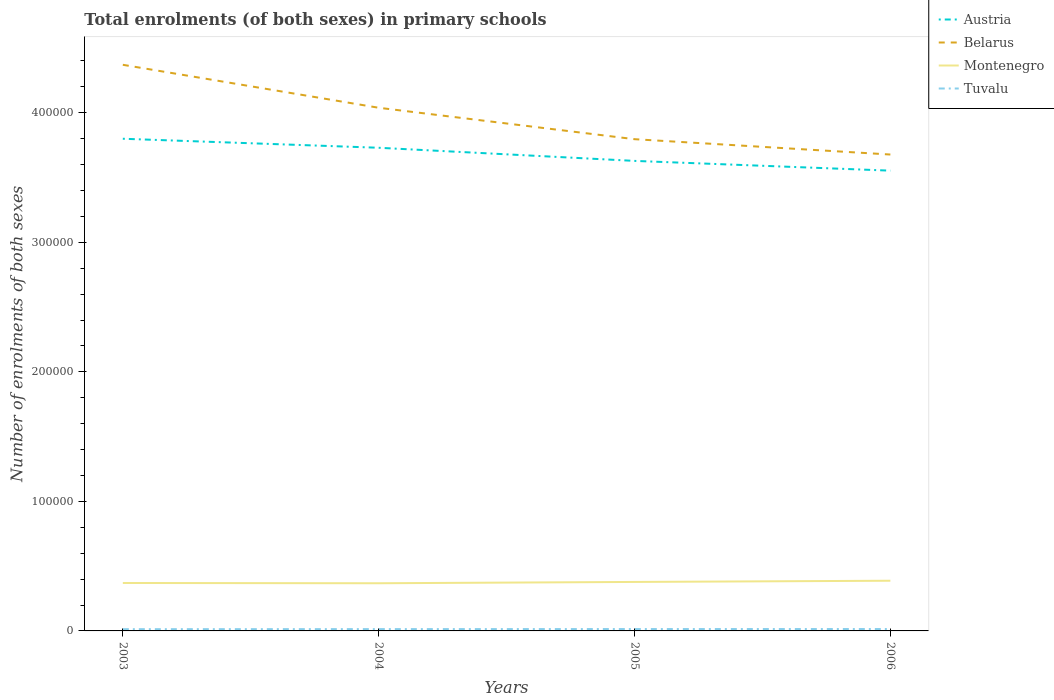How many different coloured lines are there?
Offer a very short reply. 4. Is the number of lines equal to the number of legend labels?
Provide a short and direct response. Yes. Across all years, what is the maximum number of enrolments in primary schools in Belarus?
Your answer should be compact. 3.68e+05. In which year was the number of enrolments in primary schools in Montenegro maximum?
Give a very brief answer. 2004. What is the total number of enrolments in primary schools in Belarus in the graph?
Offer a terse response. 5.74e+04. What is the difference between the highest and the second highest number of enrolments in primary schools in Montenegro?
Provide a short and direct response. 1947. What is the difference between the highest and the lowest number of enrolments in primary schools in Montenegro?
Provide a succinct answer. 2. Is the number of enrolments in primary schools in Montenegro strictly greater than the number of enrolments in primary schools in Austria over the years?
Offer a very short reply. Yes. How many lines are there?
Your answer should be compact. 4. What is the difference between two consecutive major ticks on the Y-axis?
Offer a terse response. 1.00e+05. Are the values on the major ticks of Y-axis written in scientific E-notation?
Provide a short and direct response. No. Where does the legend appear in the graph?
Keep it short and to the point. Top right. How many legend labels are there?
Give a very brief answer. 4. What is the title of the graph?
Offer a terse response. Total enrolments (of both sexes) in primary schools. What is the label or title of the X-axis?
Keep it short and to the point. Years. What is the label or title of the Y-axis?
Keep it short and to the point. Number of enrolments of both sexes. What is the Number of enrolments of both sexes of Austria in 2003?
Make the answer very short. 3.80e+05. What is the Number of enrolments of both sexes in Belarus in 2003?
Keep it short and to the point. 4.37e+05. What is the Number of enrolments of both sexes of Montenegro in 2003?
Your answer should be compact. 3.70e+04. What is the Number of enrolments of both sexes of Tuvalu in 2003?
Give a very brief answer. 1344. What is the Number of enrolments of both sexes of Austria in 2004?
Make the answer very short. 3.73e+05. What is the Number of enrolments of both sexes of Belarus in 2004?
Give a very brief answer. 4.04e+05. What is the Number of enrolments of both sexes in Montenegro in 2004?
Provide a succinct answer. 3.68e+04. What is the Number of enrolments of both sexes in Tuvalu in 2004?
Offer a terse response. 1404. What is the Number of enrolments of both sexes of Austria in 2005?
Ensure brevity in your answer.  3.63e+05. What is the Number of enrolments of both sexes in Belarus in 2005?
Give a very brief answer. 3.80e+05. What is the Number of enrolments of both sexes of Montenegro in 2005?
Offer a very short reply. 3.78e+04. What is the Number of enrolments of both sexes in Tuvalu in 2005?
Your response must be concise. 1450. What is the Number of enrolments of both sexes of Austria in 2006?
Keep it short and to the point. 3.55e+05. What is the Number of enrolments of both sexes of Belarus in 2006?
Make the answer very short. 3.68e+05. What is the Number of enrolments of both sexes in Montenegro in 2006?
Provide a short and direct response. 3.87e+04. What is the Number of enrolments of both sexes of Tuvalu in 2006?
Your response must be concise. 1460. Across all years, what is the maximum Number of enrolments of both sexes in Austria?
Keep it short and to the point. 3.80e+05. Across all years, what is the maximum Number of enrolments of both sexes of Belarus?
Your response must be concise. 4.37e+05. Across all years, what is the maximum Number of enrolments of both sexes of Montenegro?
Provide a succinct answer. 3.87e+04. Across all years, what is the maximum Number of enrolments of both sexes in Tuvalu?
Your answer should be compact. 1460. Across all years, what is the minimum Number of enrolments of both sexes of Austria?
Offer a terse response. 3.55e+05. Across all years, what is the minimum Number of enrolments of both sexes of Belarus?
Make the answer very short. 3.68e+05. Across all years, what is the minimum Number of enrolments of both sexes in Montenegro?
Provide a short and direct response. 3.68e+04. Across all years, what is the minimum Number of enrolments of both sexes in Tuvalu?
Your response must be concise. 1344. What is the total Number of enrolments of both sexes of Austria in the graph?
Your answer should be very brief. 1.47e+06. What is the total Number of enrolments of both sexes of Belarus in the graph?
Give a very brief answer. 1.59e+06. What is the total Number of enrolments of both sexes in Montenegro in the graph?
Ensure brevity in your answer.  1.50e+05. What is the total Number of enrolments of both sexes in Tuvalu in the graph?
Your answer should be very brief. 5658. What is the difference between the Number of enrolments of both sexes in Austria in 2003 and that in 2004?
Your response must be concise. 6957. What is the difference between the Number of enrolments of both sexes in Belarus in 2003 and that in 2004?
Make the answer very short. 3.32e+04. What is the difference between the Number of enrolments of both sexes of Montenegro in 2003 and that in 2004?
Offer a terse response. 216. What is the difference between the Number of enrolments of both sexes of Tuvalu in 2003 and that in 2004?
Make the answer very short. -60. What is the difference between the Number of enrolments of both sexes in Austria in 2003 and that in 2005?
Your answer should be very brief. 1.71e+04. What is the difference between the Number of enrolments of both sexes in Belarus in 2003 and that in 2005?
Your response must be concise. 5.74e+04. What is the difference between the Number of enrolments of both sexes in Montenegro in 2003 and that in 2005?
Offer a very short reply. -803. What is the difference between the Number of enrolments of both sexes of Tuvalu in 2003 and that in 2005?
Keep it short and to the point. -106. What is the difference between the Number of enrolments of both sexes in Austria in 2003 and that in 2006?
Your answer should be very brief. 2.46e+04. What is the difference between the Number of enrolments of both sexes in Belarus in 2003 and that in 2006?
Provide a short and direct response. 6.93e+04. What is the difference between the Number of enrolments of both sexes in Montenegro in 2003 and that in 2006?
Ensure brevity in your answer.  -1731. What is the difference between the Number of enrolments of both sexes in Tuvalu in 2003 and that in 2006?
Offer a terse response. -116. What is the difference between the Number of enrolments of both sexes of Austria in 2004 and that in 2005?
Give a very brief answer. 1.01e+04. What is the difference between the Number of enrolments of both sexes in Belarus in 2004 and that in 2005?
Provide a short and direct response. 2.43e+04. What is the difference between the Number of enrolments of both sexes of Montenegro in 2004 and that in 2005?
Offer a very short reply. -1019. What is the difference between the Number of enrolments of both sexes of Tuvalu in 2004 and that in 2005?
Provide a short and direct response. -46. What is the difference between the Number of enrolments of both sexes in Austria in 2004 and that in 2006?
Provide a succinct answer. 1.77e+04. What is the difference between the Number of enrolments of both sexes in Belarus in 2004 and that in 2006?
Your response must be concise. 3.61e+04. What is the difference between the Number of enrolments of both sexes in Montenegro in 2004 and that in 2006?
Give a very brief answer. -1947. What is the difference between the Number of enrolments of both sexes in Tuvalu in 2004 and that in 2006?
Make the answer very short. -56. What is the difference between the Number of enrolments of both sexes of Austria in 2005 and that in 2006?
Make the answer very short. 7529. What is the difference between the Number of enrolments of both sexes in Belarus in 2005 and that in 2006?
Give a very brief answer. 1.18e+04. What is the difference between the Number of enrolments of both sexes in Montenegro in 2005 and that in 2006?
Provide a succinct answer. -928. What is the difference between the Number of enrolments of both sexes of Tuvalu in 2005 and that in 2006?
Keep it short and to the point. -10. What is the difference between the Number of enrolments of both sexes in Austria in 2003 and the Number of enrolments of both sexes in Belarus in 2004?
Your response must be concise. -2.39e+04. What is the difference between the Number of enrolments of both sexes in Austria in 2003 and the Number of enrolments of both sexes in Montenegro in 2004?
Ensure brevity in your answer.  3.43e+05. What is the difference between the Number of enrolments of both sexes in Austria in 2003 and the Number of enrolments of both sexes in Tuvalu in 2004?
Your answer should be very brief. 3.79e+05. What is the difference between the Number of enrolments of both sexes in Belarus in 2003 and the Number of enrolments of both sexes in Montenegro in 2004?
Your response must be concise. 4.00e+05. What is the difference between the Number of enrolments of both sexes in Belarus in 2003 and the Number of enrolments of both sexes in Tuvalu in 2004?
Offer a terse response. 4.36e+05. What is the difference between the Number of enrolments of both sexes in Montenegro in 2003 and the Number of enrolments of both sexes in Tuvalu in 2004?
Your answer should be very brief. 3.56e+04. What is the difference between the Number of enrolments of both sexes in Austria in 2003 and the Number of enrolments of both sexes in Belarus in 2005?
Make the answer very short. 343. What is the difference between the Number of enrolments of both sexes of Austria in 2003 and the Number of enrolments of both sexes of Montenegro in 2005?
Offer a very short reply. 3.42e+05. What is the difference between the Number of enrolments of both sexes of Austria in 2003 and the Number of enrolments of both sexes of Tuvalu in 2005?
Your response must be concise. 3.78e+05. What is the difference between the Number of enrolments of both sexes of Belarus in 2003 and the Number of enrolments of both sexes of Montenegro in 2005?
Provide a short and direct response. 3.99e+05. What is the difference between the Number of enrolments of both sexes of Belarus in 2003 and the Number of enrolments of both sexes of Tuvalu in 2005?
Offer a very short reply. 4.36e+05. What is the difference between the Number of enrolments of both sexes of Montenegro in 2003 and the Number of enrolments of both sexes of Tuvalu in 2005?
Keep it short and to the point. 3.56e+04. What is the difference between the Number of enrolments of both sexes of Austria in 2003 and the Number of enrolments of both sexes of Belarus in 2006?
Your answer should be very brief. 1.22e+04. What is the difference between the Number of enrolments of both sexes of Austria in 2003 and the Number of enrolments of both sexes of Montenegro in 2006?
Your answer should be compact. 3.41e+05. What is the difference between the Number of enrolments of both sexes in Austria in 2003 and the Number of enrolments of both sexes in Tuvalu in 2006?
Your answer should be very brief. 3.78e+05. What is the difference between the Number of enrolments of both sexes in Belarus in 2003 and the Number of enrolments of both sexes in Montenegro in 2006?
Offer a terse response. 3.98e+05. What is the difference between the Number of enrolments of both sexes in Belarus in 2003 and the Number of enrolments of both sexes in Tuvalu in 2006?
Offer a terse response. 4.36e+05. What is the difference between the Number of enrolments of both sexes in Montenegro in 2003 and the Number of enrolments of both sexes in Tuvalu in 2006?
Offer a very short reply. 3.55e+04. What is the difference between the Number of enrolments of both sexes of Austria in 2004 and the Number of enrolments of both sexes of Belarus in 2005?
Provide a short and direct response. -6614. What is the difference between the Number of enrolments of both sexes in Austria in 2004 and the Number of enrolments of both sexes in Montenegro in 2005?
Your answer should be very brief. 3.35e+05. What is the difference between the Number of enrolments of both sexes in Austria in 2004 and the Number of enrolments of both sexes in Tuvalu in 2005?
Your answer should be very brief. 3.72e+05. What is the difference between the Number of enrolments of both sexes of Belarus in 2004 and the Number of enrolments of both sexes of Montenegro in 2005?
Ensure brevity in your answer.  3.66e+05. What is the difference between the Number of enrolments of both sexes of Belarus in 2004 and the Number of enrolments of both sexes of Tuvalu in 2005?
Offer a very short reply. 4.02e+05. What is the difference between the Number of enrolments of both sexes of Montenegro in 2004 and the Number of enrolments of both sexes of Tuvalu in 2005?
Offer a terse response. 3.53e+04. What is the difference between the Number of enrolments of both sexes of Austria in 2004 and the Number of enrolments of both sexes of Belarus in 2006?
Offer a very short reply. 5227. What is the difference between the Number of enrolments of both sexes of Austria in 2004 and the Number of enrolments of both sexes of Montenegro in 2006?
Provide a succinct answer. 3.34e+05. What is the difference between the Number of enrolments of both sexes of Austria in 2004 and the Number of enrolments of both sexes of Tuvalu in 2006?
Your answer should be very brief. 3.72e+05. What is the difference between the Number of enrolments of both sexes of Belarus in 2004 and the Number of enrolments of both sexes of Montenegro in 2006?
Keep it short and to the point. 3.65e+05. What is the difference between the Number of enrolments of both sexes of Belarus in 2004 and the Number of enrolments of both sexes of Tuvalu in 2006?
Keep it short and to the point. 4.02e+05. What is the difference between the Number of enrolments of both sexes of Montenegro in 2004 and the Number of enrolments of both sexes of Tuvalu in 2006?
Your response must be concise. 3.53e+04. What is the difference between the Number of enrolments of both sexes of Austria in 2005 and the Number of enrolments of both sexes of Belarus in 2006?
Keep it short and to the point. -4914. What is the difference between the Number of enrolments of both sexes of Austria in 2005 and the Number of enrolments of both sexes of Montenegro in 2006?
Offer a terse response. 3.24e+05. What is the difference between the Number of enrolments of both sexes in Austria in 2005 and the Number of enrolments of both sexes in Tuvalu in 2006?
Provide a short and direct response. 3.61e+05. What is the difference between the Number of enrolments of both sexes of Belarus in 2005 and the Number of enrolments of both sexes of Montenegro in 2006?
Provide a short and direct response. 3.41e+05. What is the difference between the Number of enrolments of both sexes in Belarus in 2005 and the Number of enrolments of both sexes in Tuvalu in 2006?
Keep it short and to the point. 3.78e+05. What is the difference between the Number of enrolments of both sexes of Montenegro in 2005 and the Number of enrolments of both sexes of Tuvalu in 2006?
Make the answer very short. 3.64e+04. What is the average Number of enrolments of both sexes of Austria per year?
Make the answer very short. 3.68e+05. What is the average Number of enrolments of both sexes of Belarus per year?
Offer a terse response. 3.97e+05. What is the average Number of enrolments of both sexes in Montenegro per year?
Ensure brevity in your answer.  3.76e+04. What is the average Number of enrolments of both sexes of Tuvalu per year?
Your answer should be compact. 1414.5. In the year 2003, what is the difference between the Number of enrolments of both sexes in Austria and Number of enrolments of both sexes in Belarus?
Provide a short and direct response. -5.71e+04. In the year 2003, what is the difference between the Number of enrolments of both sexes of Austria and Number of enrolments of both sexes of Montenegro?
Provide a succinct answer. 3.43e+05. In the year 2003, what is the difference between the Number of enrolments of both sexes in Austria and Number of enrolments of both sexes in Tuvalu?
Provide a succinct answer. 3.79e+05. In the year 2003, what is the difference between the Number of enrolments of both sexes of Belarus and Number of enrolments of both sexes of Montenegro?
Provide a short and direct response. 4.00e+05. In the year 2003, what is the difference between the Number of enrolments of both sexes in Belarus and Number of enrolments of both sexes in Tuvalu?
Your response must be concise. 4.36e+05. In the year 2003, what is the difference between the Number of enrolments of both sexes in Montenegro and Number of enrolments of both sexes in Tuvalu?
Make the answer very short. 3.57e+04. In the year 2004, what is the difference between the Number of enrolments of both sexes in Austria and Number of enrolments of both sexes in Belarus?
Ensure brevity in your answer.  -3.09e+04. In the year 2004, what is the difference between the Number of enrolments of both sexes of Austria and Number of enrolments of both sexes of Montenegro?
Keep it short and to the point. 3.36e+05. In the year 2004, what is the difference between the Number of enrolments of both sexes in Austria and Number of enrolments of both sexes in Tuvalu?
Your response must be concise. 3.72e+05. In the year 2004, what is the difference between the Number of enrolments of both sexes in Belarus and Number of enrolments of both sexes in Montenegro?
Give a very brief answer. 3.67e+05. In the year 2004, what is the difference between the Number of enrolments of both sexes in Belarus and Number of enrolments of both sexes in Tuvalu?
Your response must be concise. 4.02e+05. In the year 2004, what is the difference between the Number of enrolments of both sexes in Montenegro and Number of enrolments of both sexes in Tuvalu?
Provide a short and direct response. 3.54e+04. In the year 2005, what is the difference between the Number of enrolments of both sexes in Austria and Number of enrolments of both sexes in Belarus?
Your response must be concise. -1.68e+04. In the year 2005, what is the difference between the Number of enrolments of both sexes in Austria and Number of enrolments of both sexes in Montenegro?
Make the answer very short. 3.25e+05. In the year 2005, what is the difference between the Number of enrolments of both sexes in Austria and Number of enrolments of both sexes in Tuvalu?
Make the answer very short. 3.61e+05. In the year 2005, what is the difference between the Number of enrolments of both sexes in Belarus and Number of enrolments of both sexes in Montenegro?
Offer a terse response. 3.42e+05. In the year 2005, what is the difference between the Number of enrolments of both sexes in Belarus and Number of enrolments of both sexes in Tuvalu?
Keep it short and to the point. 3.78e+05. In the year 2005, what is the difference between the Number of enrolments of both sexes of Montenegro and Number of enrolments of both sexes of Tuvalu?
Your response must be concise. 3.64e+04. In the year 2006, what is the difference between the Number of enrolments of both sexes in Austria and Number of enrolments of both sexes in Belarus?
Keep it short and to the point. -1.24e+04. In the year 2006, what is the difference between the Number of enrolments of both sexes of Austria and Number of enrolments of both sexes of Montenegro?
Offer a very short reply. 3.17e+05. In the year 2006, what is the difference between the Number of enrolments of both sexes of Austria and Number of enrolments of both sexes of Tuvalu?
Provide a succinct answer. 3.54e+05. In the year 2006, what is the difference between the Number of enrolments of both sexes of Belarus and Number of enrolments of both sexes of Montenegro?
Give a very brief answer. 3.29e+05. In the year 2006, what is the difference between the Number of enrolments of both sexes of Belarus and Number of enrolments of both sexes of Tuvalu?
Offer a terse response. 3.66e+05. In the year 2006, what is the difference between the Number of enrolments of both sexes in Montenegro and Number of enrolments of both sexes in Tuvalu?
Ensure brevity in your answer.  3.73e+04. What is the ratio of the Number of enrolments of both sexes of Austria in 2003 to that in 2004?
Make the answer very short. 1.02. What is the ratio of the Number of enrolments of both sexes in Belarus in 2003 to that in 2004?
Your answer should be compact. 1.08. What is the ratio of the Number of enrolments of both sexes of Montenegro in 2003 to that in 2004?
Your answer should be compact. 1.01. What is the ratio of the Number of enrolments of both sexes in Tuvalu in 2003 to that in 2004?
Ensure brevity in your answer.  0.96. What is the ratio of the Number of enrolments of both sexes in Austria in 2003 to that in 2005?
Provide a short and direct response. 1.05. What is the ratio of the Number of enrolments of both sexes of Belarus in 2003 to that in 2005?
Offer a very short reply. 1.15. What is the ratio of the Number of enrolments of both sexes of Montenegro in 2003 to that in 2005?
Your answer should be very brief. 0.98. What is the ratio of the Number of enrolments of both sexes in Tuvalu in 2003 to that in 2005?
Offer a terse response. 0.93. What is the ratio of the Number of enrolments of both sexes in Austria in 2003 to that in 2006?
Make the answer very short. 1.07. What is the ratio of the Number of enrolments of both sexes of Belarus in 2003 to that in 2006?
Offer a terse response. 1.19. What is the ratio of the Number of enrolments of both sexes in Montenegro in 2003 to that in 2006?
Make the answer very short. 0.96. What is the ratio of the Number of enrolments of both sexes of Tuvalu in 2003 to that in 2006?
Provide a succinct answer. 0.92. What is the ratio of the Number of enrolments of both sexes in Austria in 2004 to that in 2005?
Your response must be concise. 1.03. What is the ratio of the Number of enrolments of both sexes of Belarus in 2004 to that in 2005?
Provide a succinct answer. 1.06. What is the ratio of the Number of enrolments of both sexes of Montenegro in 2004 to that in 2005?
Your response must be concise. 0.97. What is the ratio of the Number of enrolments of both sexes in Tuvalu in 2004 to that in 2005?
Ensure brevity in your answer.  0.97. What is the ratio of the Number of enrolments of both sexes of Austria in 2004 to that in 2006?
Your answer should be compact. 1.05. What is the ratio of the Number of enrolments of both sexes in Belarus in 2004 to that in 2006?
Provide a succinct answer. 1.1. What is the ratio of the Number of enrolments of both sexes in Montenegro in 2004 to that in 2006?
Your answer should be very brief. 0.95. What is the ratio of the Number of enrolments of both sexes in Tuvalu in 2004 to that in 2006?
Keep it short and to the point. 0.96. What is the ratio of the Number of enrolments of both sexes in Austria in 2005 to that in 2006?
Provide a short and direct response. 1.02. What is the ratio of the Number of enrolments of both sexes in Belarus in 2005 to that in 2006?
Make the answer very short. 1.03. What is the ratio of the Number of enrolments of both sexes in Montenegro in 2005 to that in 2006?
Provide a succinct answer. 0.98. What is the difference between the highest and the second highest Number of enrolments of both sexes in Austria?
Your answer should be compact. 6957. What is the difference between the highest and the second highest Number of enrolments of both sexes in Belarus?
Provide a short and direct response. 3.32e+04. What is the difference between the highest and the second highest Number of enrolments of both sexes of Montenegro?
Your answer should be compact. 928. What is the difference between the highest and the lowest Number of enrolments of both sexes in Austria?
Provide a short and direct response. 2.46e+04. What is the difference between the highest and the lowest Number of enrolments of both sexes in Belarus?
Keep it short and to the point. 6.93e+04. What is the difference between the highest and the lowest Number of enrolments of both sexes in Montenegro?
Give a very brief answer. 1947. What is the difference between the highest and the lowest Number of enrolments of both sexes of Tuvalu?
Keep it short and to the point. 116. 